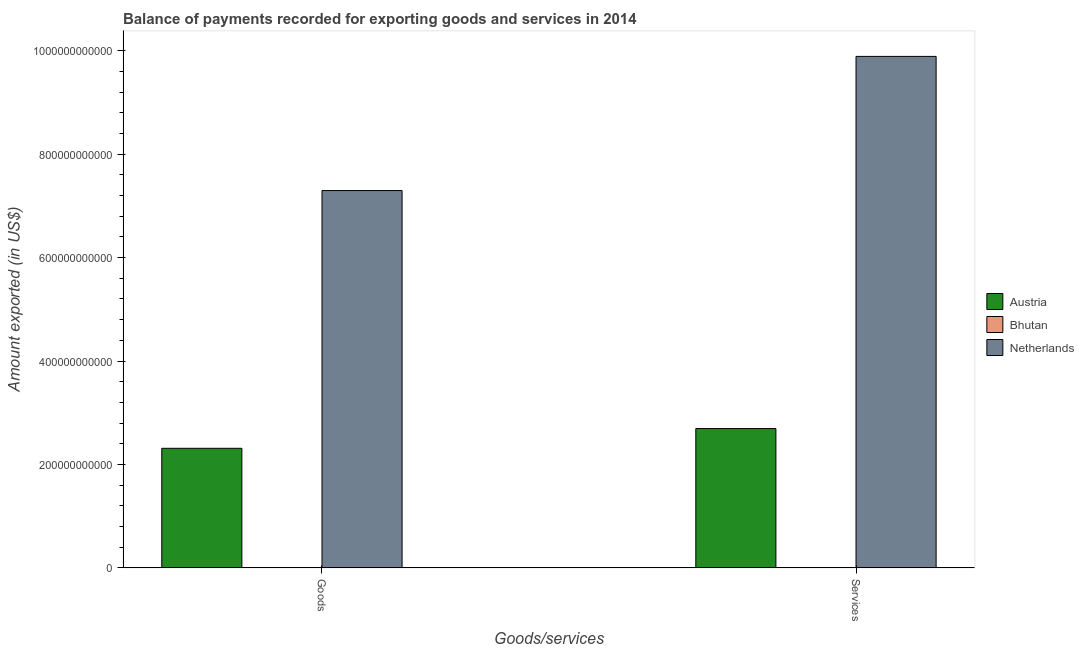How many different coloured bars are there?
Provide a succinct answer. 3. How many groups of bars are there?
Your answer should be compact. 2. Are the number of bars per tick equal to the number of legend labels?
Your answer should be compact. Yes. What is the label of the 2nd group of bars from the left?
Your response must be concise. Services. What is the amount of goods exported in Netherlands?
Keep it short and to the point. 7.30e+11. Across all countries, what is the maximum amount of goods exported?
Offer a terse response. 7.30e+11. Across all countries, what is the minimum amount of goods exported?
Your response must be concise. 6.67e+08. In which country was the amount of goods exported maximum?
Offer a terse response. Netherlands. In which country was the amount of services exported minimum?
Your response must be concise. Bhutan. What is the total amount of services exported in the graph?
Offer a terse response. 1.26e+12. What is the difference between the amount of services exported in Netherlands and that in Austria?
Give a very brief answer. 7.19e+11. What is the difference between the amount of goods exported in Bhutan and the amount of services exported in Netherlands?
Offer a terse response. -9.88e+11. What is the average amount of services exported per country?
Your answer should be very brief. 4.20e+11. What is the difference between the amount of services exported and amount of goods exported in Netherlands?
Offer a terse response. 2.59e+11. In how many countries, is the amount of goods exported greater than 360000000000 US$?
Your answer should be compact. 1. What is the ratio of the amount of goods exported in Austria to that in Bhutan?
Make the answer very short. 346.77. What does the 3rd bar from the left in Goods represents?
Offer a very short reply. Netherlands. Are all the bars in the graph horizontal?
Ensure brevity in your answer.  No. What is the difference between two consecutive major ticks on the Y-axis?
Your answer should be very brief. 2.00e+11. How many legend labels are there?
Offer a very short reply. 3. What is the title of the graph?
Make the answer very short. Balance of payments recorded for exporting goods and services in 2014. Does "South Africa" appear as one of the legend labels in the graph?
Your answer should be compact. No. What is the label or title of the X-axis?
Provide a succinct answer. Goods/services. What is the label or title of the Y-axis?
Ensure brevity in your answer.  Amount exported (in US$). What is the Amount exported (in US$) in Austria in Goods?
Provide a short and direct response. 2.31e+11. What is the Amount exported (in US$) in Bhutan in Goods?
Offer a terse response. 6.67e+08. What is the Amount exported (in US$) of Netherlands in Goods?
Your answer should be compact. 7.30e+11. What is the Amount exported (in US$) of Austria in Services?
Give a very brief answer. 2.70e+11. What is the Amount exported (in US$) in Bhutan in Services?
Your answer should be very brief. 6.86e+08. What is the Amount exported (in US$) in Netherlands in Services?
Offer a very short reply. 9.89e+11. Across all Goods/services, what is the maximum Amount exported (in US$) of Austria?
Provide a short and direct response. 2.70e+11. Across all Goods/services, what is the maximum Amount exported (in US$) in Bhutan?
Keep it short and to the point. 6.86e+08. Across all Goods/services, what is the maximum Amount exported (in US$) in Netherlands?
Your answer should be very brief. 9.89e+11. Across all Goods/services, what is the minimum Amount exported (in US$) in Austria?
Make the answer very short. 2.31e+11. Across all Goods/services, what is the minimum Amount exported (in US$) of Bhutan?
Keep it short and to the point. 6.67e+08. Across all Goods/services, what is the minimum Amount exported (in US$) in Netherlands?
Your response must be concise. 7.30e+11. What is the total Amount exported (in US$) of Austria in the graph?
Offer a very short reply. 5.01e+11. What is the total Amount exported (in US$) of Bhutan in the graph?
Provide a short and direct response. 1.35e+09. What is the total Amount exported (in US$) in Netherlands in the graph?
Make the answer very short. 1.72e+12. What is the difference between the Amount exported (in US$) in Austria in Goods and that in Services?
Provide a short and direct response. -3.82e+1. What is the difference between the Amount exported (in US$) in Bhutan in Goods and that in Services?
Provide a short and direct response. -1.90e+07. What is the difference between the Amount exported (in US$) in Netherlands in Goods and that in Services?
Offer a very short reply. -2.59e+11. What is the difference between the Amount exported (in US$) of Austria in Goods and the Amount exported (in US$) of Bhutan in Services?
Your answer should be very brief. 2.31e+11. What is the difference between the Amount exported (in US$) of Austria in Goods and the Amount exported (in US$) of Netherlands in Services?
Give a very brief answer. -7.58e+11. What is the difference between the Amount exported (in US$) of Bhutan in Goods and the Amount exported (in US$) of Netherlands in Services?
Your answer should be compact. -9.88e+11. What is the average Amount exported (in US$) of Austria per Goods/services?
Offer a terse response. 2.50e+11. What is the average Amount exported (in US$) in Bhutan per Goods/services?
Your response must be concise. 6.77e+08. What is the average Amount exported (in US$) of Netherlands per Goods/services?
Provide a succinct answer. 8.59e+11. What is the difference between the Amount exported (in US$) of Austria and Amount exported (in US$) of Bhutan in Goods?
Ensure brevity in your answer.  2.31e+11. What is the difference between the Amount exported (in US$) in Austria and Amount exported (in US$) in Netherlands in Goods?
Keep it short and to the point. -4.98e+11. What is the difference between the Amount exported (in US$) in Bhutan and Amount exported (in US$) in Netherlands in Goods?
Provide a short and direct response. -7.29e+11. What is the difference between the Amount exported (in US$) of Austria and Amount exported (in US$) of Bhutan in Services?
Keep it short and to the point. 2.69e+11. What is the difference between the Amount exported (in US$) of Austria and Amount exported (in US$) of Netherlands in Services?
Keep it short and to the point. -7.19e+11. What is the difference between the Amount exported (in US$) of Bhutan and Amount exported (in US$) of Netherlands in Services?
Your response must be concise. -9.88e+11. What is the ratio of the Amount exported (in US$) in Austria in Goods to that in Services?
Provide a succinct answer. 0.86. What is the ratio of the Amount exported (in US$) in Bhutan in Goods to that in Services?
Offer a terse response. 0.97. What is the ratio of the Amount exported (in US$) of Netherlands in Goods to that in Services?
Provide a succinct answer. 0.74. What is the difference between the highest and the second highest Amount exported (in US$) in Austria?
Make the answer very short. 3.82e+1. What is the difference between the highest and the second highest Amount exported (in US$) in Bhutan?
Provide a short and direct response. 1.90e+07. What is the difference between the highest and the second highest Amount exported (in US$) in Netherlands?
Keep it short and to the point. 2.59e+11. What is the difference between the highest and the lowest Amount exported (in US$) of Austria?
Keep it short and to the point. 3.82e+1. What is the difference between the highest and the lowest Amount exported (in US$) in Bhutan?
Your answer should be very brief. 1.90e+07. What is the difference between the highest and the lowest Amount exported (in US$) in Netherlands?
Provide a succinct answer. 2.59e+11. 